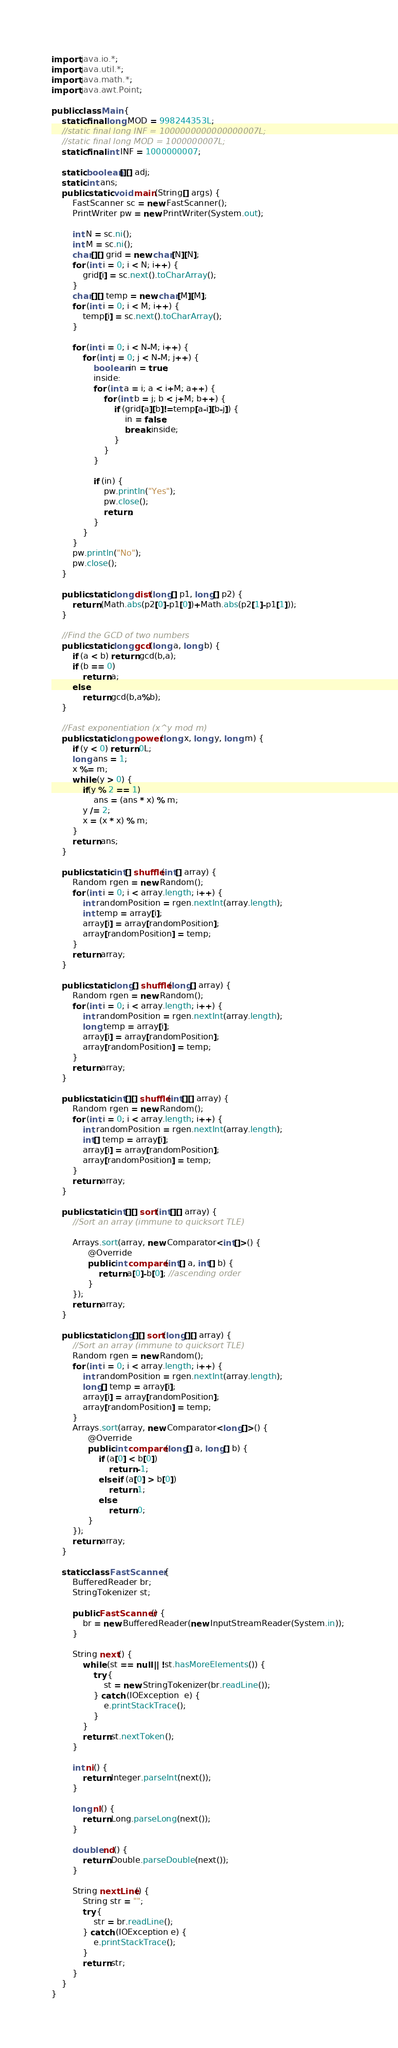Convert code to text. <code><loc_0><loc_0><loc_500><loc_500><_Java_>import java.io.*;
import java.util.*;
import java.math.*;
import java.awt.Point;
 
public class Main {
	static final long MOD = 998244353L;
	//static final long INF = 1000000000000000007L;
	//static final long MOD = 1000000007L;
	static final int INF = 1000000007;
	
	static boolean[][] adj;
	static int ans;
	public static void main(String[] args) {
		FastScanner sc = new FastScanner();
		PrintWriter pw = new PrintWriter(System.out);
		
		int N = sc.ni();
		int M = sc.ni();
		char[][] grid = new char[N][N];
		for (int i = 0; i < N; i++) {
			grid[i] = sc.next().toCharArray();
		}
		char[][] temp = new char[M][M];
		for (int i = 0; i < M; i++) {
			temp[i] = sc.next().toCharArray();
		}
		
		for (int i = 0; i < N-M; i++) {
			for (int j = 0; j < N-M; j++) {
				boolean in = true;
				inside:
				for (int a = i; a < i+M; a++) {
					for (int b = j; b < j+M; b++) {
						if (grid[a][b]!=temp[a-i][b-j]) {
							in = false;
							break inside;
						}
					}
				}
				
				if (in) {
					pw.println("Yes");
					pw.close();
					return;
				}
			}
		}
		pw.println("No");
		pw.close();
	}
 
	public static long dist(long[] p1, long[] p2) {
		return (Math.abs(p2[0]-p1[0])+Math.abs(p2[1]-p1[1]));
	}
	
	//Find the GCD of two numbers
	public static long gcd(long a, long b) {
		if (a < b) return gcd(b,a);
		if (b == 0)
			return a;
		else
			return gcd(b,a%b);
	}
	
	//Fast exponentiation (x^y mod m)
	public static long power(long x, long y, long m) { 
		if (y < 0) return 0L;
		long ans = 1;
		x %= m;
		while (y > 0) { 
			if(y % 2 == 1) 
				ans = (ans * x) % m; 
			y /= 2;  
			x = (x * x) % m;
		} 
		return ans; 
	}
	
	public static int[] shuffle(int[] array) {
		Random rgen = new Random();
		for (int i = 0; i < array.length; i++) {
		    int randomPosition = rgen.nextInt(array.length);
		    int temp = array[i];
		    array[i] = array[randomPosition];
		    array[randomPosition] = temp;
		}
		return array;
	}
	
	public static long[] shuffle(long[] array) {
		Random rgen = new Random();
		for (int i = 0; i < array.length; i++) {
		    int randomPosition = rgen.nextInt(array.length);
		    long temp = array[i];
		    array[i] = array[randomPosition];
		    array[randomPosition] = temp;
		}
		return array;
	}
	
	public static int[][] shuffle(int[][] array) {
		Random rgen = new Random();
		for (int i = 0; i < array.length; i++) {
		    int randomPosition = rgen.nextInt(array.length);
		    int[] temp = array[i];
		    array[i] = array[randomPosition];
		    array[randomPosition] = temp;
		}
		return array;
	}
	
    public static int[][] sort(int[][] array) {
    	//Sort an array (immune to quicksort TLE)
 
		Arrays.sort(array, new Comparator<int[]>() {
			  @Override
        	  public int compare(int[] a, int[] b) {
				  return a[0]-b[0]; //ascending order
	          }
		});
		return array;
	}
    
    public static long[][] sort(long[][] array) {
    	//Sort an array (immune to quicksort TLE)
		Random rgen = new Random();
		for (int i = 0; i < array.length; i++) {
		    int randomPosition = rgen.nextInt(array.length);
		    long[] temp = array[i];
		    array[i] = array[randomPosition];
		    array[randomPosition] = temp;
		}
		Arrays.sort(array, new Comparator<long[]>() {
			  @Override
        	  public int compare(long[] a, long[] b) {
				  if (a[0] < b[0])
					  return -1;
				  else if (a[0] > b[0])
					  return 1;
				  else
					  return 0;
	          }
		});
		return array;
	}
    
    static class FastScanner { 
        BufferedReader br; 
        StringTokenizer st; 
  
        public FastScanner() { 
            br = new BufferedReader(new InputStreamReader(System.in)); 
        } 
  
        String next() { 
            while (st == null || !st.hasMoreElements()) { 
                try { 
                    st = new StringTokenizer(br.readLine());
                } catch (IOException  e) { 
                    e.printStackTrace(); 
                } 
            } 
            return st.nextToken(); 
        }
        
        int ni() { 
            return Integer.parseInt(next()); 
        }
  
        long nl() { 
            return Long.parseLong(next()); 
        } 
  
        double nd() { 
            return Double.parseDouble(next()); 
        } 
  
        String nextLine() {
            String str = ""; 
            try { 
                str = br.readLine(); 
            } catch (IOException e) {
                e.printStackTrace(); 
            } 
            return str;
        }
    }
}</code> 